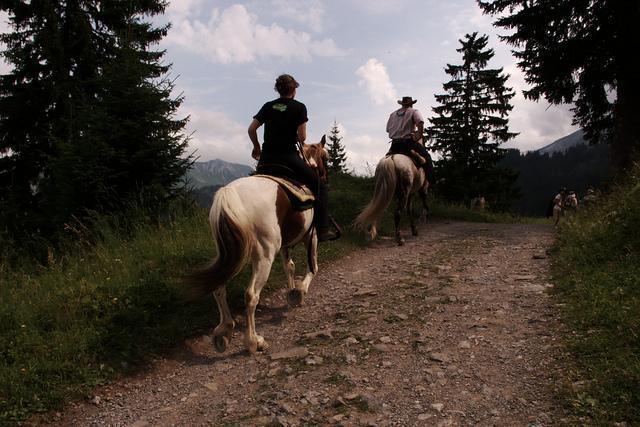How many people are in this picture?
Give a very brief answer. 5. How many horses are there?
Give a very brief answer. 2. How many horses can be seen?
Give a very brief answer. 2. How many bananas are cut up in total?
Give a very brief answer. 0. 